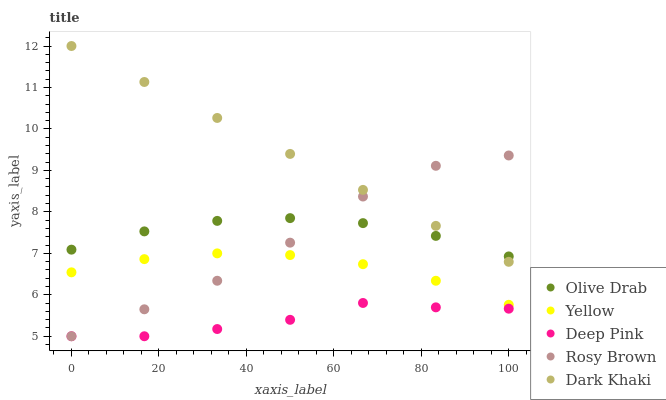Does Deep Pink have the minimum area under the curve?
Answer yes or no. Yes. Does Dark Khaki have the maximum area under the curve?
Answer yes or no. Yes. Does Rosy Brown have the minimum area under the curve?
Answer yes or no. No. Does Rosy Brown have the maximum area under the curve?
Answer yes or no. No. Is Dark Khaki the smoothest?
Answer yes or no. Yes. Is Rosy Brown the roughest?
Answer yes or no. Yes. Is Deep Pink the smoothest?
Answer yes or no. No. Is Deep Pink the roughest?
Answer yes or no. No. Does Rosy Brown have the lowest value?
Answer yes or no. Yes. Does Yellow have the lowest value?
Answer yes or no. No. Does Dark Khaki have the highest value?
Answer yes or no. Yes. Does Rosy Brown have the highest value?
Answer yes or no. No. Is Yellow less than Dark Khaki?
Answer yes or no. Yes. Is Dark Khaki greater than Deep Pink?
Answer yes or no. Yes. Does Olive Drab intersect Rosy Brown?
Answer yes or no. Yes. Is Olive Drab less than Rosy Brown?
Answer yes or no. No. Is Olive Drab greater than Rosy Brown?
Answer yes or no. No. Does Yellow intersect Dark Khaki?
Answer yes or no. No. 